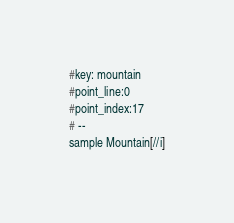Convert code to text. <code><loc_0><loc_0><loc_500><loc_500><_Scheme_>#key: mountain
#point_line:0
#point_index:17
# --
sample Mountain[//i]
</code> 